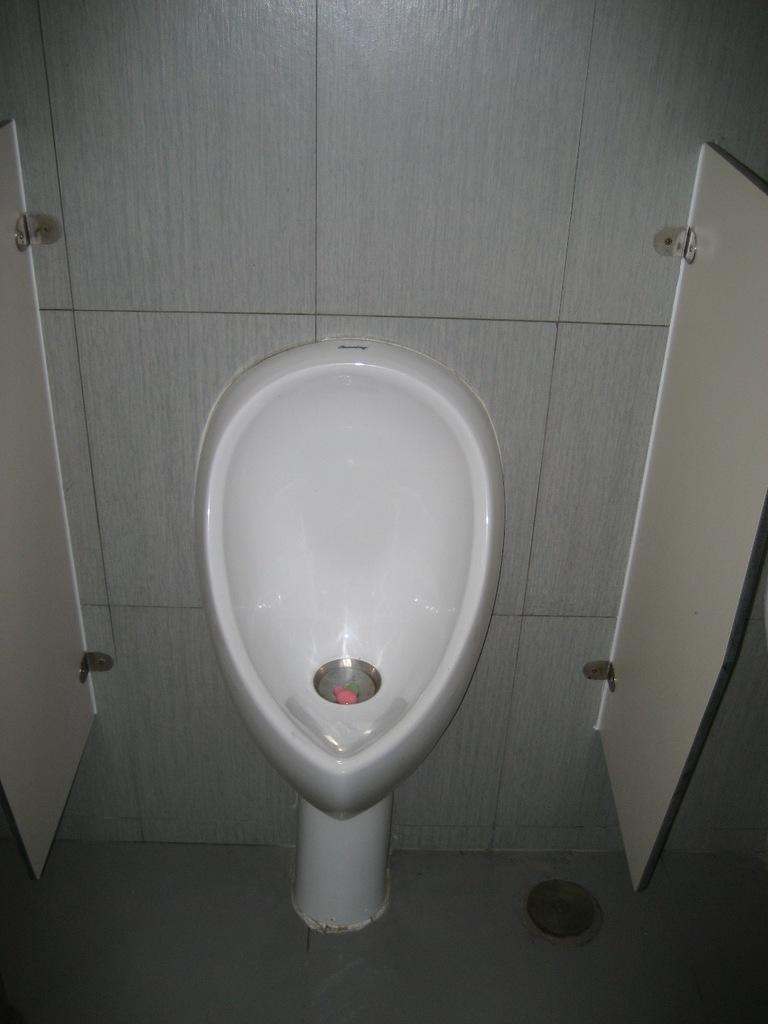Could you give a brief overview of what you see in this image? As we can see in the image there are white color tiles and western toilet. 